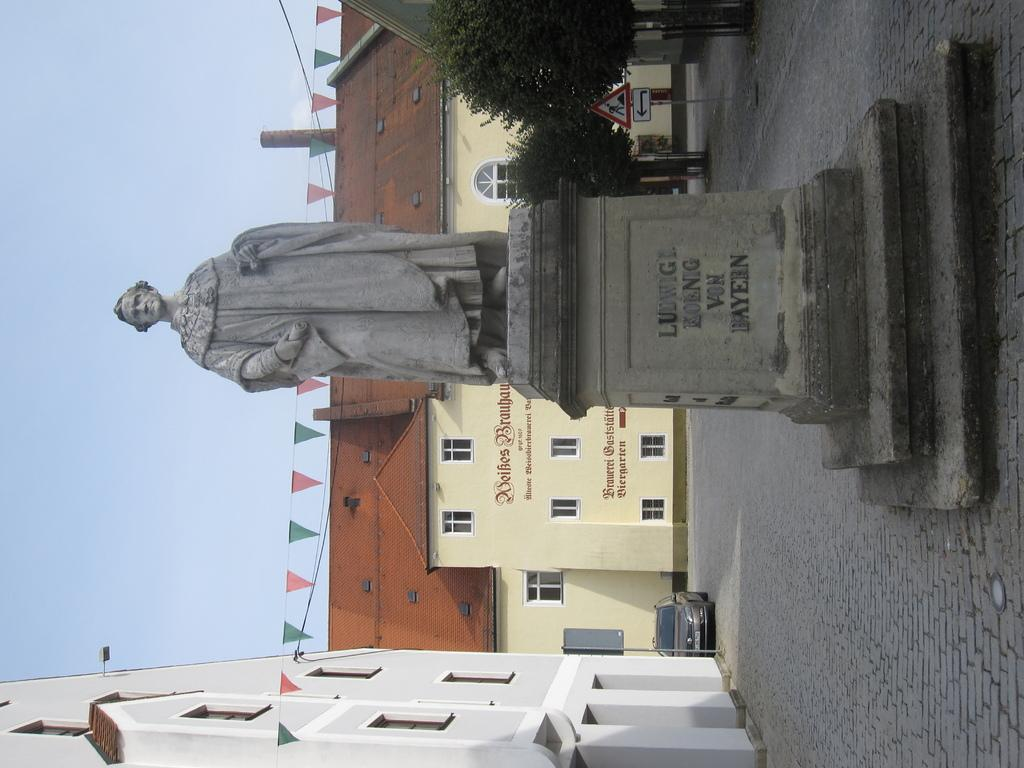<image>
Present a compact description of the photo's key features. A statue of "Ludwig" is shown in a city square in front of a yellow building. 